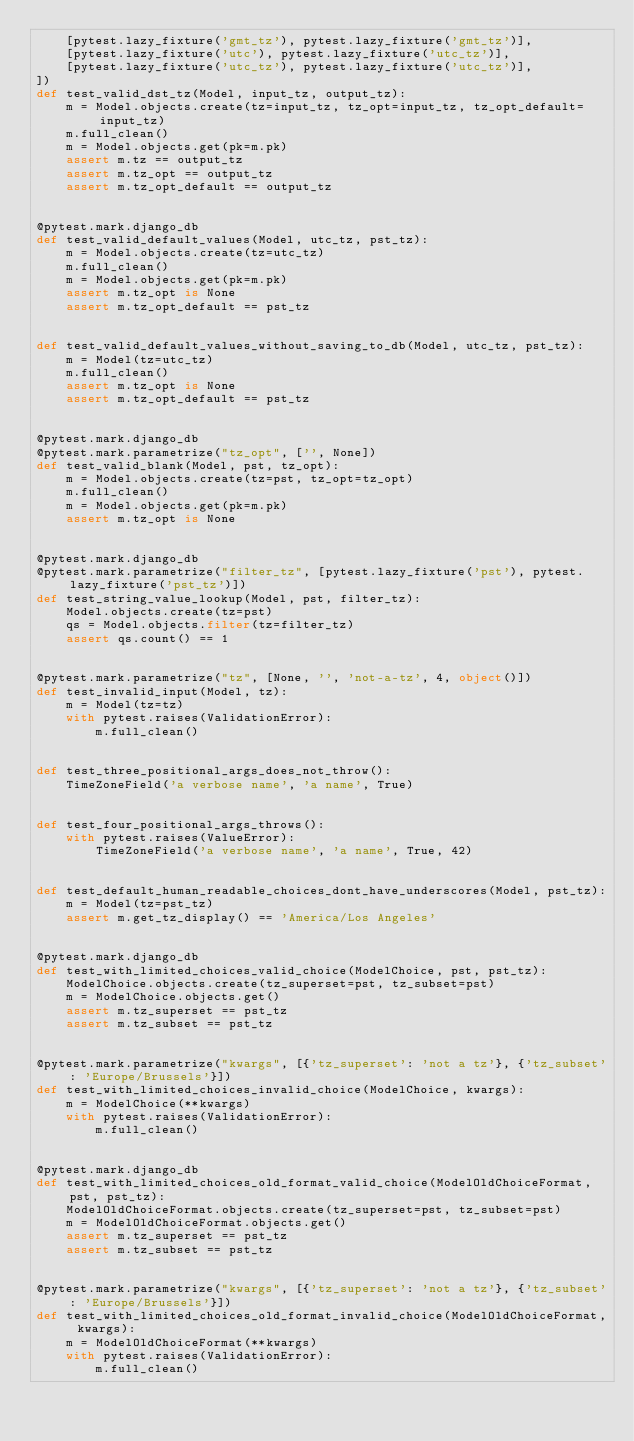<code> <loc_0><loc_0><loc_500><loc_500><_Python_>    [pytest.lazy_fixture('gmt_tz'), pytest.lazy_fixture('gmt_tz')],
    [pytest.lazy_fixture('utc'), pytest.lazy_fixture('utc_tz')],
    [pytest.lazy_fixture('utc_tz'), pytest.lazy_fixture('utc_tz')],
])
def test_valid_dst_tz(Model, input_tz, output_tz):
    m = Model.objects.create(tz=input_tz, tz_opt=input_tz, tz_opt_default=input_tz)
    m.full_clean()
    m = Model.objects.get(pk=m.pk)
    assert m.tz == output_tz
    assert m.tz_opt == output_tz
    assert m.tz_opt_default == output_tz


@pytest.mark.django_db
def test_valid_default_values(Model, utc_tz, pst_tz):
    m = Model.objects.create(tz=utc_tz)
    m.full_clean()
    m = Model.objects.get(pk=m.pk)
    assert m.tz_opt is None
    assert m.tz_opt_default == pst_tz


def test_valid_default_values_without_saving_to_db(Model, utc_tz, pst_tz):
    m = Model(tz=utc_tz)
    m.full_clean()
    assert m.tz_opt is None
    assert m.tz_opt_default == pst_tz


@pytest.mark.django_db
@pytest.mark.parametrize("tz_opt", ['', None])
def test_valid_blank(Model, pst, tz_opt):
    m = Model.objects.create(tz=pst, tz_opt=tz_opt)
    m.full_clean()
    m = Model.objects.get(pk=m.pk)
    assert m.tz_opt is None


@pytest.mark.django_db
@pytest.mark.parametrize("filter_tz", [pytest.lazy_fixture('pst'), pytest.lazy_fixture('pst_tz')])
def test_string_value_lookup(Model, pst, filter_tz):
    Model.objects.create(tz=pst)
    qs = Model.objects.filter(tz=filter_tz)
    assert qs.count() == 1


@pytest.mark.parametrize("tz", [None, '', 'not-a-tz', 4, object()])
def test_invalid_input(Model, tz):
    m = Model(tz=tz)
    with pytest.raises(ValidationError):
        m.full_clean()


def test_three_positional_args_does_not_throw():
    TimeZoneField('a verbose name', 'a name', True)


def test_four_positional_args_throws():
    with pytest.raises(ValueError):
        TimeZoneField('a verbose name', 'a name', True, 42)


def test_default_human_readable_choices_dont_have_underscores(Model, pst_tz):
    m = Model(tz=pst_tz)
    assert m.get_tz_display() == 'America/Los Angeles'


@pytest.mark.django_db
def test_with_limited_choices_valid_choice(ModelChoice, pst, pst_tz):
    ModelChoice.objects.create(tz_superset=pst, tz_subset=pst)
    m = ModelChoice.objects.get()
    assert m.tz_superset == pst_tz
    assert m.tz_subset == pst_tz


@pytest.mark.parametrize("kwargs", [{'tz_superset': 'not a tz'}, {'tz_subset': 'Europe/Brussels'}])
def test_with_limited_choices_invalid_choice(ModelChoice, kwargs):
    m = ModelChoice(**kwargs)
    with pytest.raises(ValidationError):
        m.full_clean()


@pytest.mark.django_db
def test_with_limited_choices_old_format_valid_choice(ModelOldChoiceFormat, pst, pst_tz):
    ModelOldChoiceFormat.objects.create(tz_superset=pst, tz_subset=pst)
    m = ModelOldChoiceFormat.objects.get()
    assert m.tz_superset == pst_tz
    assert m.tz_subset == pst_tz


@pytest.mark.parametrize("kwargs", [{'tz_superset': 'not a tz'}, {'tz_subset': 'Europe/Brussels'}])
def test_with_limited_choices_old_format_invalid_choice(ModelOldChoiceFormat, kwargs):
    m = ModelOldChoiceFormat(**kwargs)
    with pytest.raises(ValidationError):
        m.full_clean()
</code> 